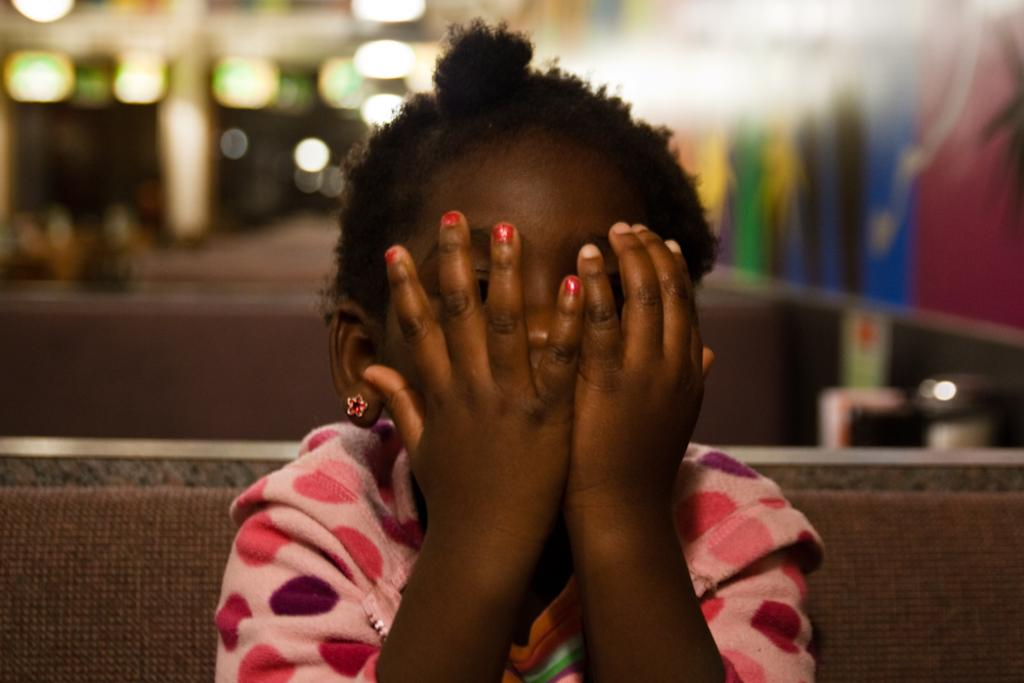Who is the main subject in the image? There is a girl in the image. What is the girl doing with her hands? The girl is covering her face with her hands. Where is the girl sitting? The girl is sitting on a bench. What type of brain can be seen in the image? There is no brain visible in the image; it features a girl covering her face with her hands while sitting on a bench. 